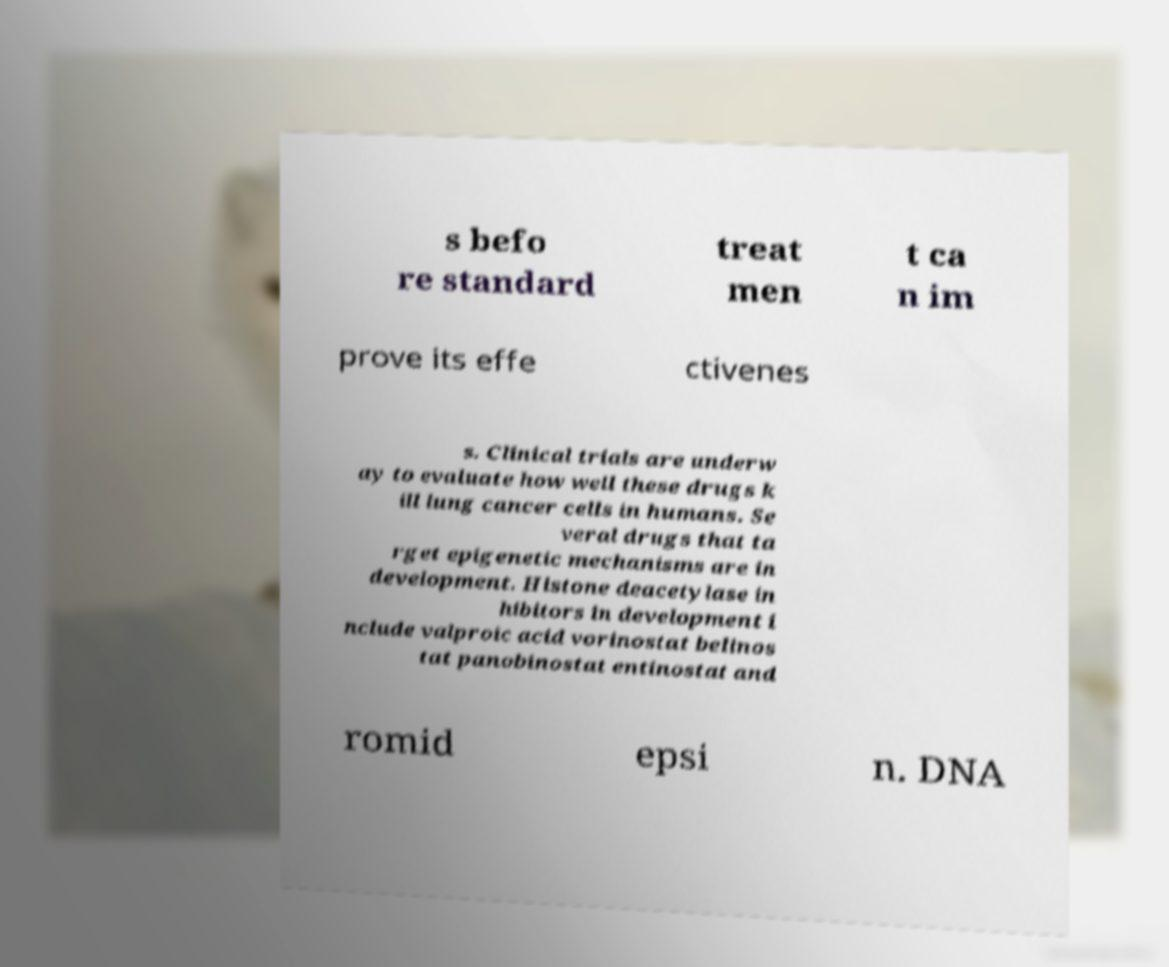Can you accurately transcribe the text from the provided image for me? s befo re standard treat men t ca n im prove its effe ctivenes s. Clinical trials are underw ay to evaluate how well these drugs k ill lung cancer cells in humans. Se veral drugs that ta rget epigenetic mechanisms are in development. Histone deacetylase in hibitors in development i nclude valproic acid vorinostat belinos tat panobinostat entinostat and romid epsi n. DNA 